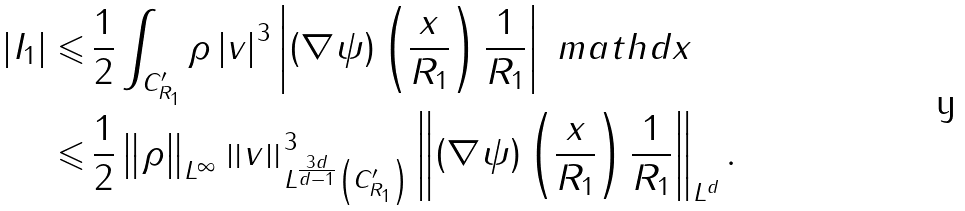<formula> <loc_0><loc_0><loc_500><loc_500>\left | I _ { 1 } \right | \leqslant & \, \frac { 1 } { 2 } \int _ { C _ { R _ { 1 } } ^ { \prime } } \rho \left | v \right | ^ { 3 } \left | \left ( \nabla \psi \right ) \left ( \frac { x } { R _ { 1 } } \right ) \frac { 1 } { R _ { 1 } } \right | \ m a t h d x \\ \leqslant & \, \frac { 1 } { 2 } \left \| \rho \right \| _ { L ^ { \infty } } \left \| v \right \| ^ { 3 } _ { L ^ { \frac { 3 d } { d - 1 } } \left ( C _ { R _ { 1 } } ^ { \prime } \right ) } \left \| \left ( \nabla \psi \right ) \left ( \frac { x } { R _ { 1 } } \right ) \frac { 1 } { R _ { 1 } } \right \| _ { L ^ { d } } .</formula> 